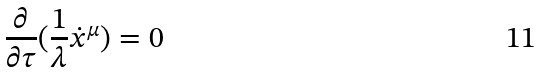Convert formula to latex. <formula><loc_0><loc_0><loc_500><loc_500>\frac { \partial } { \partial \tau } ( \frac { 1 } { \lambda } \dot { x } ^ { \mu } ) = 0</formula> 